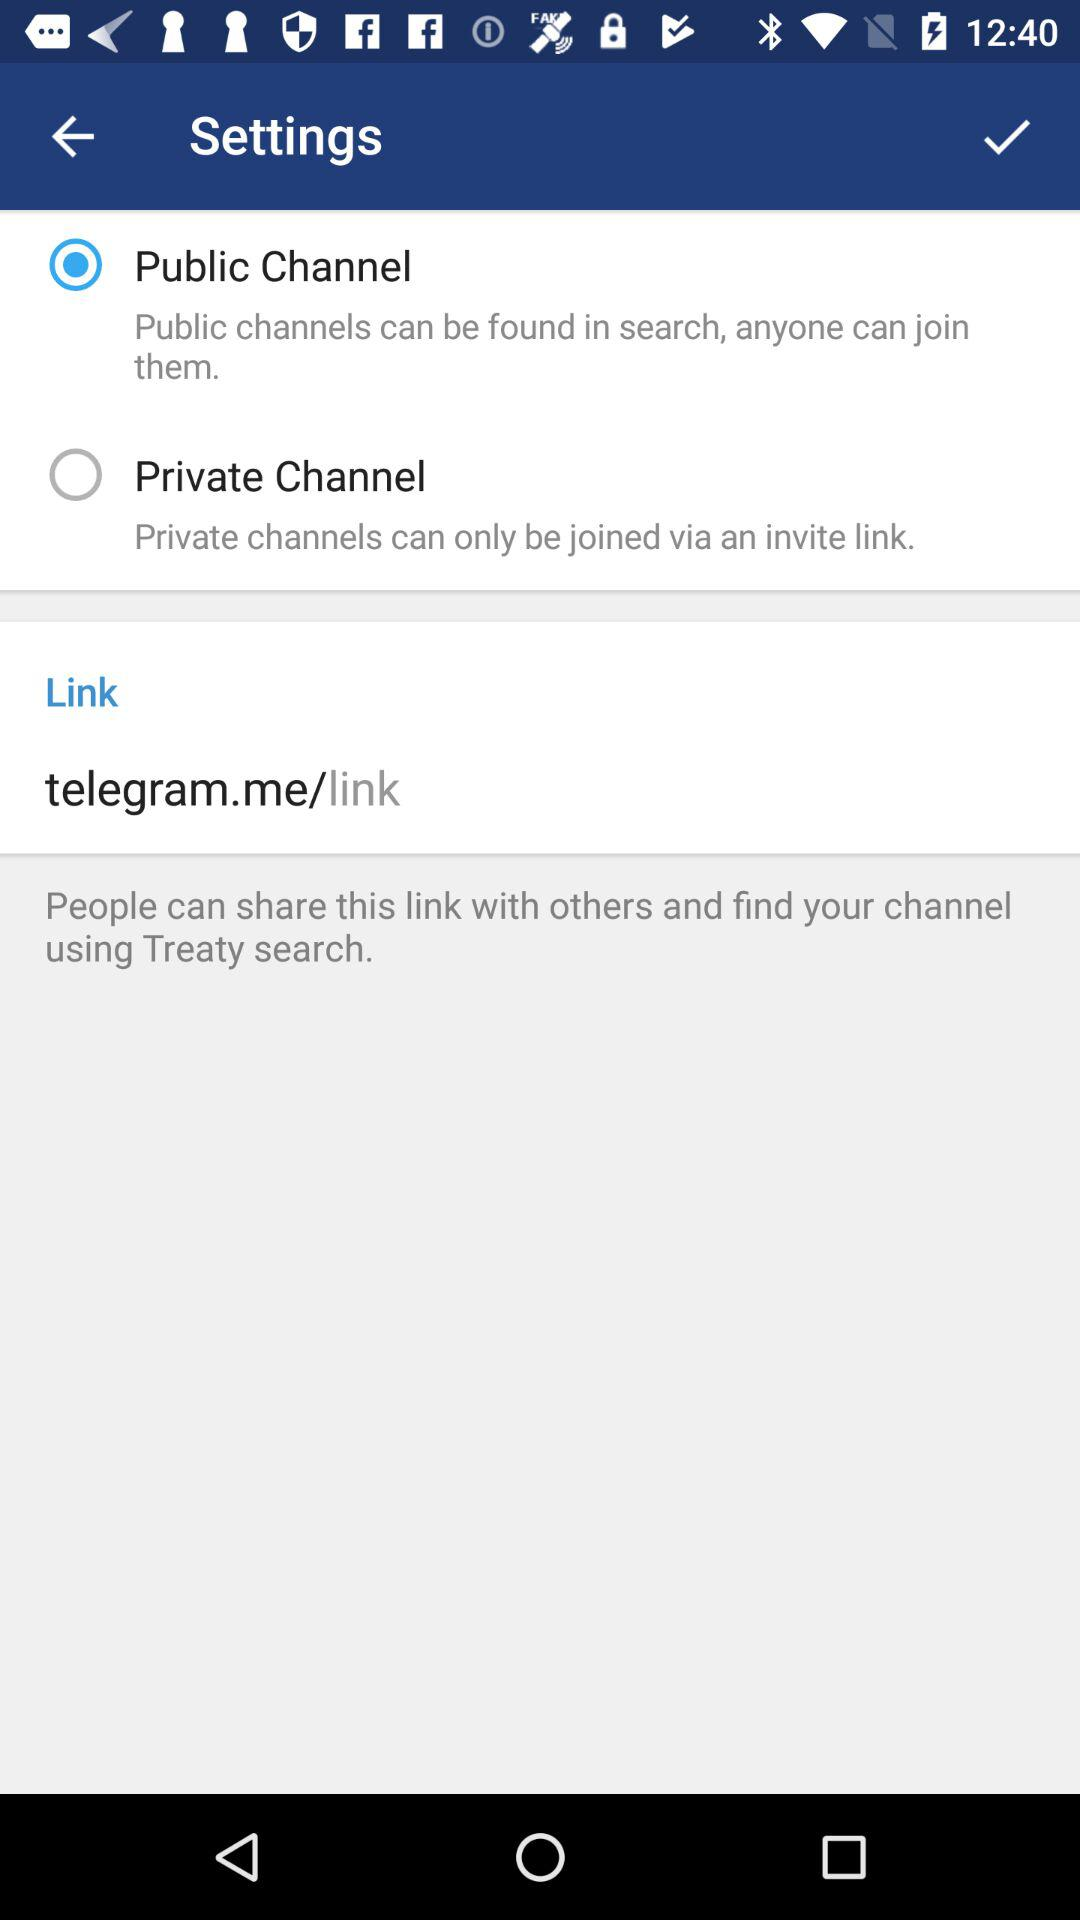What is the given link? The given link is "telegram.me/link". 